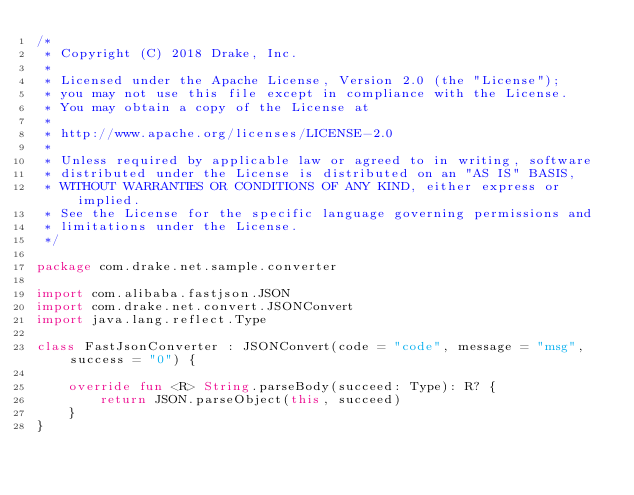Convert code to text. <code><loc_0><loc_0><loc_500><loc_500><_Kotlin_>/*
 * Copyright (C) 2018 Drake, Inc.
 *
 * Licensed under the Apache License, Version 2.0 (the "License");
 * you may not use this file except in compliance with the License.
 * You may obtain a copy of the License at
 *
 * http://www.apache.org/licenses/LICENSE-2.0
 *
 * Unless required by applicable law or agreed to in writing, software
 * distributed under the License is distributed on an "AS IS" BASIS,
 * WITHOUT WARRANTIES OR CONDITIONS OF ANY KIND, either express or implied.
 * See the License for the specific language governing permissions and
 * limitations under the License.
 */

package com.drake.net.sample.converter

import com.alibaba.fastjson.JSON
import com.drake.net.convert.JSONConvert
import java.lang.reflect.Type

class FastJsonConverter : JSONConvert(code = "code", message = "msg", success = "0") {

    override fun <R> String.parseBody(succeed: Type): R? {
        return JSON.parseObject(this, succeed)
    }
}</code> 